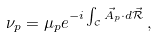Convert formula to latex. <formula><loc_0><loc_0><loc_500><loc_500>\nu _ { p } = \mu _ { p } e ^ { - i \int _ { \mathcal { C } } \vec { A } _ { p } \cdot d \vec { \mathcal { R } } } \, ,</formula> 